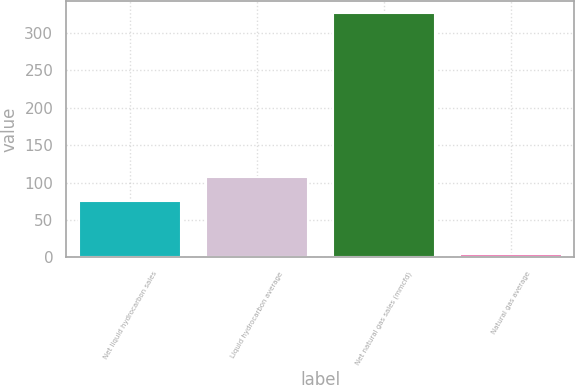Convert chart to OTSL. <chart><loc_0><loc_0><loc_500><loc_500><bar_chart><fcel>Net liquid hydrocarbon sales<fcel>Liquid hydrocarbon average<fcel>Net natural gas sales (mmcfd)<fcel>Natural gas average<nl><fcel>75<fcel>107.11<fcel>326<fcel>4.95<nl></chart> 